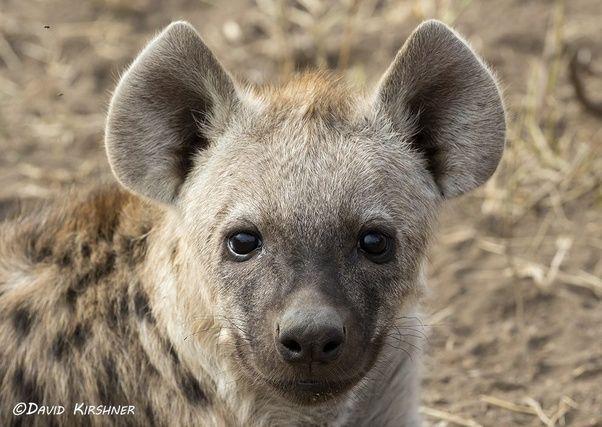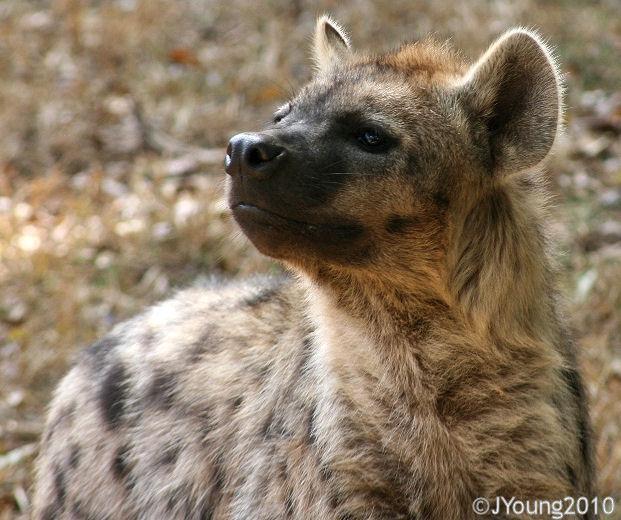The first image is the image on the left, the second image is the image on the right. Given the left and right images, does the statement "The hyena on the left is a close up of its face at it looks at the camera." hold true? Answer yes or no. Yes. 